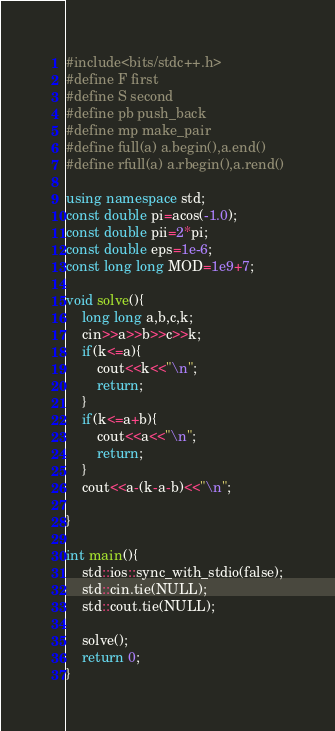Convert code to text. <code><loc_0><loc_0><loc_500><loc_500><_C++_>#include<bits/stdc++.h>
#define F first
#define S second
#define pb push_back
#define mp make_pair
#define full(a) a.begin(),a.end()
#define rfull(a) a.rbegin(),a.rend()

using namespace std;
const double pi=acos(-1.0);
const double pii=2*pi;
const double eps=1e-6;
const long long MOD=1e9+7;

void solve(){
    long long a,b,c,k;
    cin>>a>>b>>c>>k;
    if(k<=a){
        cout<<k<<"\n";
        return;
    }
    if(k<=a+b){
        cout<<a<<"\n";
        return;
    }
    cout<<a-(k-a-b)<<"\n";
    
}

int main(){
    std::ios::sync_with_stdio(false);
    std::cin.tie(NULL);
    std::cout.tie(NULL);

    solve();
    return 0;
}</code> 